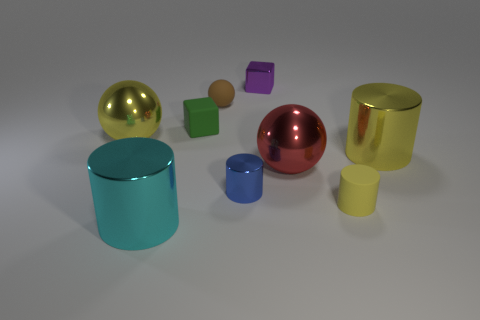How many cylinders are the same material as the purple cube?
Make the answer very short. 3. What number of rubber spheres are to the left of the tiny yellow rubber cylinder?
Make the answer very short. 1. What is the size of the yellow rubber cylinder?
Ensure brevity in your answer.  Small. What is the color of the sphere that is the same size as the blue cylinder?
Offer a terse response. Brown. Are there any big spheres of the same color as the tiny metal block?
Ensure brevity in your answer.  No. What material is the tiny green cube?
Ensure brevity in your answer.  Rubber. What number of red rubber things are there?
Keep it short and to the point. 0. Is the color of the large ball to the left of the purple shiny block the same as the big cylinder right of the blue object?
Your answer should be compact. Yes. What is the size of the metallic sphere that is the same color as the tiny rubber cylinder?
Your response must be concise. Large. What number of other things are there of the same size as the red shiny ball?
Give a very brief answer. 3. 